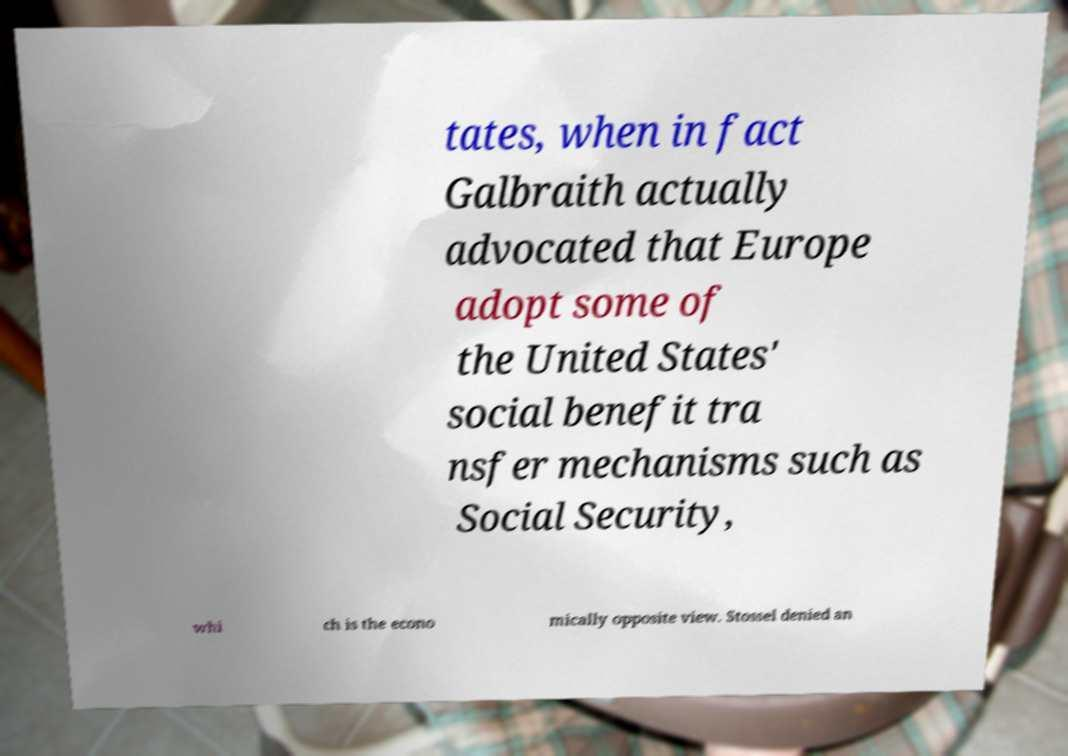For documentation purposes, I need the text within this image transcribed. Could you provide that? tates, when in fact Galbraith actually advocated that Europe adopt some of the United States' social benefit tra nsfer mechanisms such as Social Security, whi ch is the econo mically opposite view. Stossel denied an 